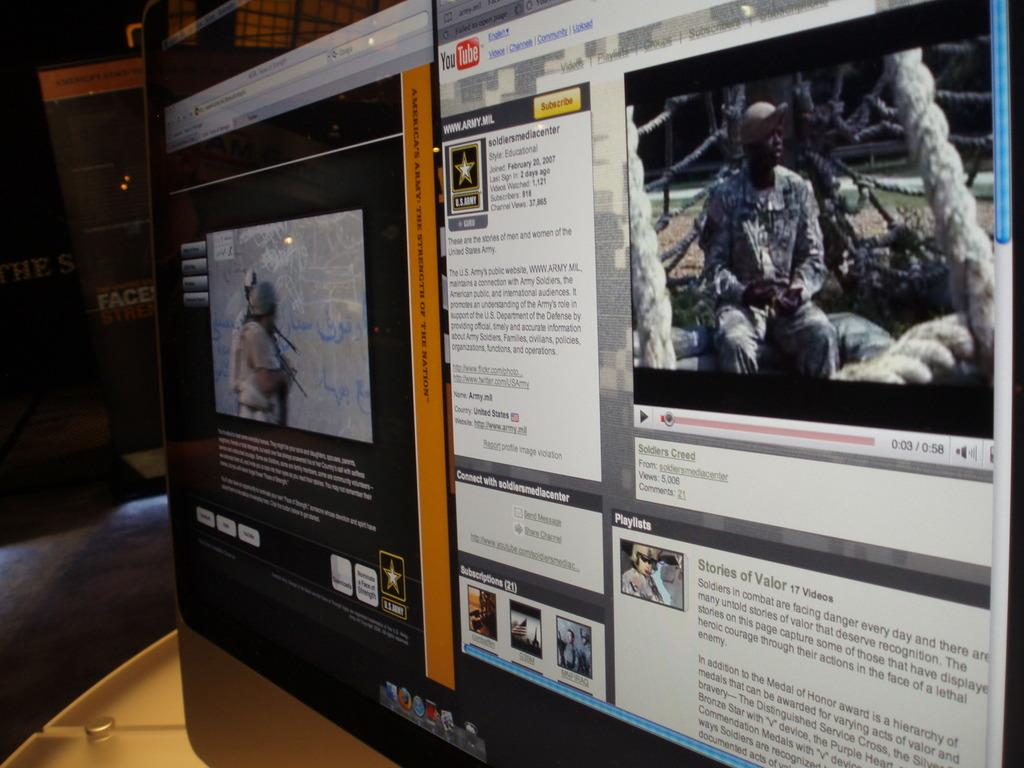Provide a one-sentence caption for the provided image. A computer screen shows a You Tube page featuring soldiers. 